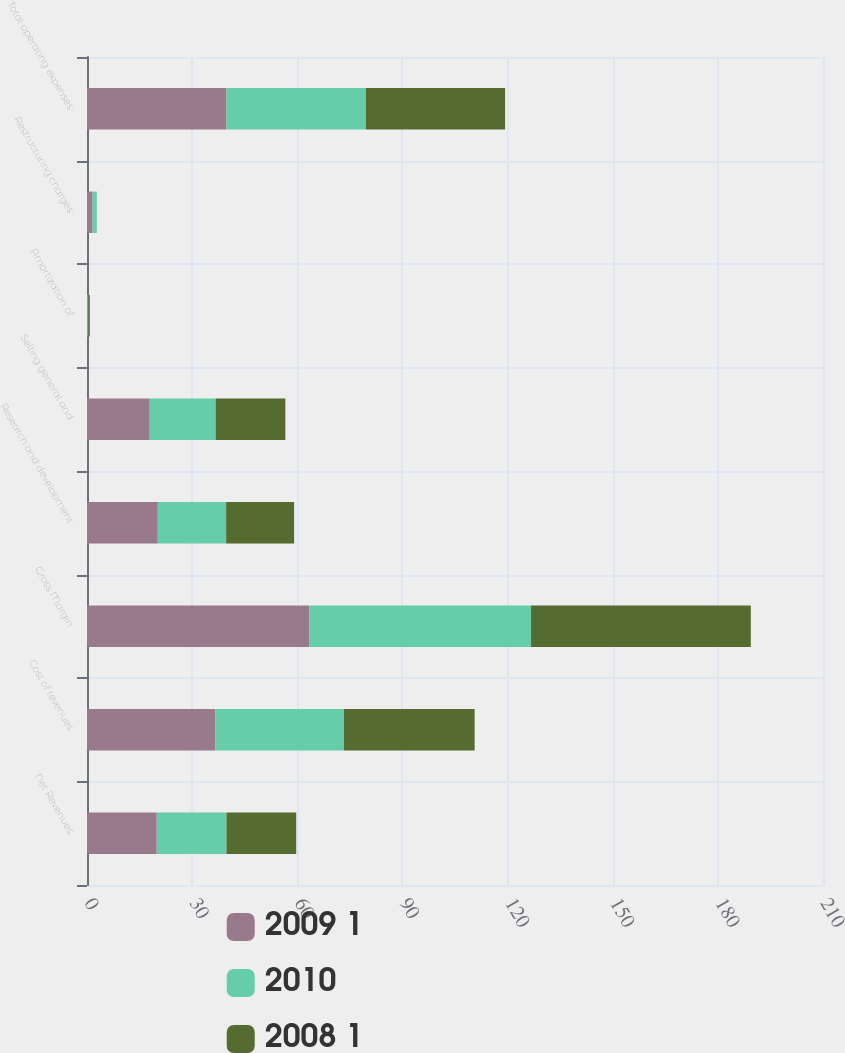<chart> <loc_0><loc_0><loc_500><loc_500><stacked_bar_chart><ecel><fcel>Net Revenues<fcel>Cost of revenues<fcel>Gross Margin<fcel>Research and development<fcel>Selling general and<fcel>Amortization of<fcel>Restructuring charges<fcel>Total operating expenses<nl><fcel>2009 1<fcel>19.9<fcel>36.6<fcel>63.4<fcel>20.2<fcel>17.9<fcel>0.1<fcel>1.6<fcel>39.8<nl><fcel>2010<fcel>19.9<fcel>36.7<fcel>63.3<fcel>19.5<fcel>18.8<fcel>0.3<fcel>1.2<fcel>39.8<nl><fcel>2008 1<fcel>19.9<fcel>37.3<fcel>62.7<fcel>19.4<fcel>19.9<fcel>0.4<fcel>0<fcel>39.7<nl></chart> 